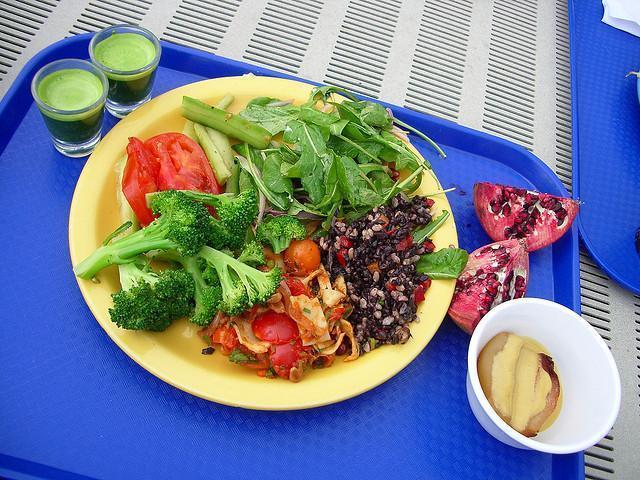How many broccolis are there?
Give a very brief answer. 2. How many cups are there?
Give a very brief answer. 2. 